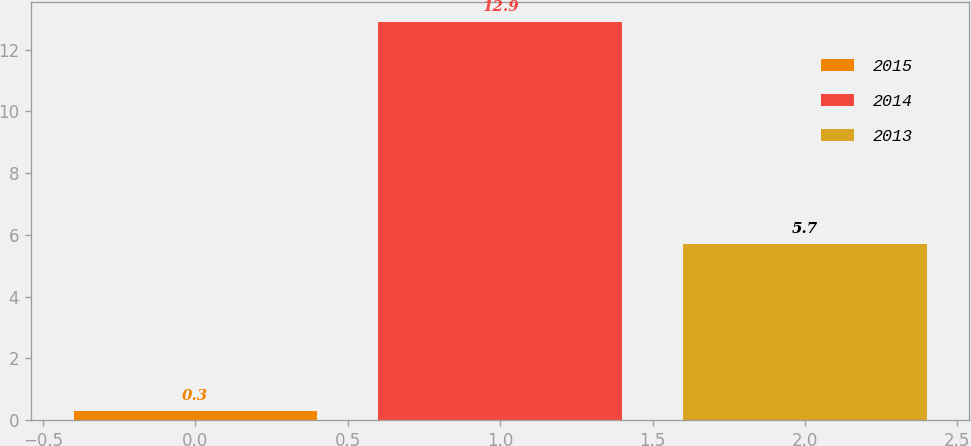Convert chart. <chart><loc_0><loc_0><loc_500><loc_500><bar_chart><fcel>2015<fcel>2014<fcel>2013<nl><fcel>0.3<fcel>12.9<fcel>5.7<nl></chart> 